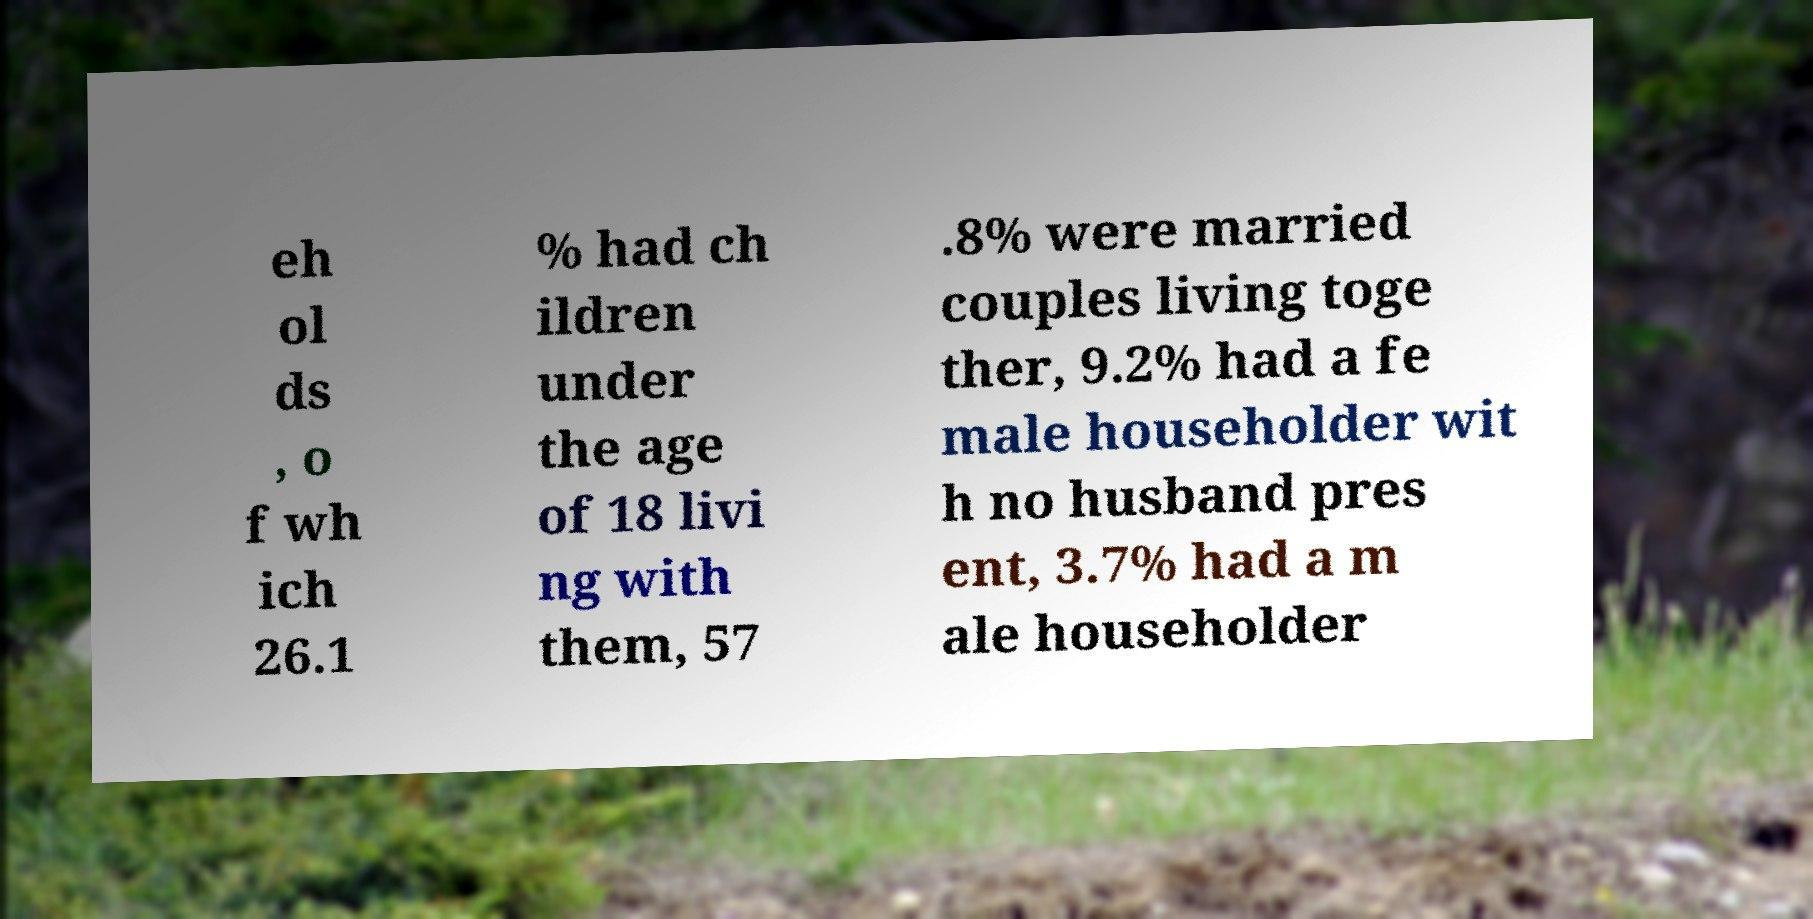For documentation purposes, I need the text within this image transcribed. Could you provide that? eh ol ds , o f wh ich 26.1 % had ch ildren under the age of 18 livi ng with them, 57 .8% were married couples living toge ther, 9.2% had a fe male householder wit h no husband pres ent, 3.7% had a m ale householder 